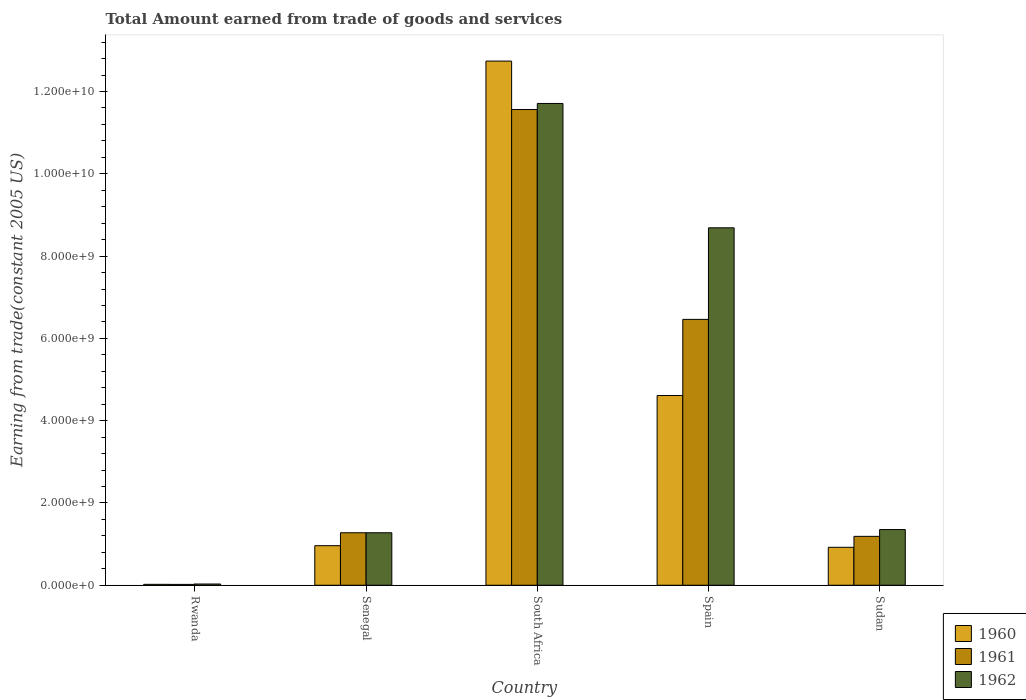How many different coloured bars are there?
Make the answer very short. 3. How many bars are there on the 3rd tick from the left?
Offer a very short reply. 3. How many bars are there on the 1st tick from the right?
Make the answer very short. 3. What is the label of the 2nd group of bars from the left?
Ensure brevity in your answer.  Senegal. In how many cases, is the number of bars for a given country not equal to the number of legend labels?
Keep it short and to the point. 0. What is the total amount earned by trading goods and services in 1962 in Sudan?
Give a very brief answer. 1.35e+09. Across all countries, what is the maximum total amount earned by trading goods and services in 1962?
Your answer should be very brief. 1.17e+1. Across all countries, what is the minimum total amount earned by trading goods and services in 1960?
Give a very brief answer. 2.20e+07. In which country was the total amount earned by trading goods and services in 1960 maximum?
Your answer should be compact. South Africa. In which country was the total amount earned by trading goods and services in 1960 minimum?
Provide a succinct answer. Rwanda. What is the total total amount earned by trading goods and services in 1960 in the graph?
Ensure brevity in your answer.  1.93e+1. What is the difference between the total amount earned by trading goods and services in 1962 in South Africa and that in Sudan?
Offer a very short reply. 1.04e+1. What is the difference between the total amount earned by trading goods and services in 1962 in South Africa and the total amount earned by trading goods and services in 1961 in Spain?
Ensure brevity in your answer.  5.25e+09. What is the average total amount earned by trading goods and services in 1961 per country?
Your answer should be very brief. 4.10e+09. What is the difference between the total amount earned by trading goods and services of/in 1962 and total amount earned by trading goods and services of/in 1960 in Spain?
Offer a very short reply. 4.08e+09. What is the ratio of the total amount earned by trading goods and services in 1962 in Senegal to that in Sudan?
Your answer should be compact. 0.94. Is the total amount earned by trading goods and services in 1960 in Senegal less than that in South Africa?
Give a very brief answer. Yes. What is the difference between the highest and the second highest total amount earned by trading goods and services in 1961?
Provide a succinct answer. -5.19e+09. What is the difference between the highest and the lowest total amount earned by trading goods and services in 1962?
Provide a succinct answer. 1.17e+1. Is it the case that in every country, the sum of the total amount earned by trading goods and services in 1961 and total amount earned by trading goods and services in 1962 is greater than the total amount earned by trading goods and services in 1960?
Give a very brief answer. Yes. Are all the bars in the graph horizontal?
Ensure brevity in your answer.  No. How many countries are there in the graph?
Make the answer very short. 5. What is the difference between two consecutive major ticks on the Y-axis?
Your answer should be compact. 2.00e+09. Does the graph contain any zero values?
Provide a short and direct response. No. Where does the legend appear in the graph?
Your answer should be compact. Bottom right. How are the legend labels stacked?
Ensure brevity in your answer.  Vertical. What is the title of the graph?
Offer a terse response. Total Amount earned from trade of goods and services. What is the label or title of the Y-axis?
Provide a succinct answer. Earning from trade(constant 2005 US). What is the Earning from trade(constant 2005 US) of 1960 in Rwanda?
Provide a short and direct response. 2.20e+07. What is the Earning from trade(constant 2005 US) in 1961 in Rwanda?
Provide a short and direct response. 2.05e+07. What is the Earning from trade(constant 2005 US) of 1962 in Rwanda?
Give a very brief answer. 2.97e+07. What is the Earning from trade(constant 2005 US) of 1960 in Senegal?
Your answer should be compact. 9.62e+08. What is the Earning from trade(constant 2005 US) in 1961 in Senegal?
Give a very brief answer. 1.28e+09. What is the Earning from trade(constant 2005 US) in 1962 in Senegal?
Provide a short and direct response. 1.28e+09. What is the Earning from trade(constant 2005 US) of 1960 in South Africa?
Offer a terse response. 1.27e+1. What is the Earning from trade(constant 2005 US) in 1961 in South Africa?
Provide a succinct answer. 1.16e+1. What is the Earning from trade(constant 2005 US) in 1962 in South Africa?
Ensure brevity in your answer.  1.17e+1. What is the Earning from trade(constant 2005 US) in 1960 in Spain?
Ensure brevity in your answer.  4.61e+09. What is the Earning from trade(constant 2005 US) in 1961 in Spain?
Give a very brief answer. 6.46e+09. What is the Earning from trade(constant 2005 US) in 1962 in Spain?
Give a very brief answer. 8.69e+09. What is the Earning from trade(constant 2005 US) of 1960 in Sudan?
Keep it short and to the point. 9.22e+08. What is the Earning from trade(constant 2005 US) of 1961 in Sudan?
Provide a short and direct response. 1.19e+09. What is the Earning from trade(constant 2005 US) of 1962 in Sudan?
Offer a very short reply. 1.35e+09. Across all countries, what is the maximum Earning from trade(constant 2005 US) in 1960?
Your answer should be very brief. 1.27e+1. Across all countries, what is the maximum Earning from trade(constant 2005 US) of 1961?
Your response must be concise. 1.16e+1. Across all countries, what is the maximum Earning from trade(constant 2005 US) of 1962?
Make the answer very short. 1.17e+1. Across all countries, what is the minimum Earning from trade(constant 2005 US) of 1960?
Ensure brevity in your answer.  2.20e+07. Across all countries, what is the minimum Earning from trade(constant 2005 US) of 1961?
Offer a very short reply. 2.05e+07. Across all countries, what is the minimum Earning from trade(constant 2005 US) in 1962?
Your answer should be compact. 2.97e+07. What is the total Earning from trade(constant 2005 US) in 1960 in the graph?
Provide a succinct answer. 1.93e+1. What is the total Earning from trade(constant 2005 US) of 1961 in the graph?
Your answer should be compact. 2.05e+1. What is the total Earning from trade(constant 2005 US) of 1962 in the graph?
Give a very brief answer. 2.31e+1. What is the difference between the Earning from trade(constant 2005 US) of 1960 in Rwanda and that in Senegal?
Provide a succinct answer. -9.40e+08. What is the difference between the Earning from trade(constant 2005 US) in 1961 in Rwanda and that in Senegal?
Ensure brevity in your answer.  -1.26e+09. What is the difference between the Earning from trade(constant 2005 US) in 1962 in Rwanda and that in Senegal?
Provide a short and direct response. -1.25e+09. What is the difference between the Earning from trade(constant 2005 US) in 1960 in Rwanda and that in South Africa?
Provide a short and direct response. -1.27e+1. What is the difference between the Earning from trade(constant 2005 US) in 1961 in Rwanda and that in South Africa?
Offer a terse response. -1.15e+1. What is the difference between the Earning from trade(constant 2005 US) of 1962 in Rwanda and that in South Africa?
Give a very brief answer. -1.17e+1. What is the difference between the Earning from trade(constant 2005 US) of 1960 in Rwanda and that in Spain?
Keep it short and to the point. -4.59e+09. What is the difference between the Earning from trade(constant 2005 US) of 1961 in Rwanda and that in Spain?
Your answer should be compact. -6.44e+09. What is the difference between the Earning from trade(constant 2005 US) of 1962 in Rwanda and that in Spain?
Ensure brevity in your answer.  -8.66e+09. What is the difference between the Earning from trade(constant 2005 US) of 1960 in Rwanda and that in Sudan?
Give a very brief answer. -9.00e+08. What is the difference between the Earning from trade(constant 2005 US) of 1961 in Rwanda and that in Sudan?
Offer a terse response. -1.17e+09. What is the difference between the Earning from trade(constant 2005 US) in 1962 in Rwanda and that in Sudan?
Your response must be concise. -1.32e+09. What is the difference between the Earning from trade(constant 2005 US) in 1960 in Senegal and that in South Africa?
Make the answer very short. -1.18e+1. What is the difference between the Earning from trade(constant 2005 US) of 1961 in Senegal and that in South Africa?
Your response must be concise. -1.03e+1. What is the difference between the Earning from trade(constant 2005 US) in 1962 in Senegal and that in South Africa?
Offer a terse response. -1.04e+1. What is the difference between the Earning from trade(constant 2005 US) in 1960 in Senegal and that in Spain?
Make the answer very short. -3.65e+09. What is the difference between the Earning from trade(constant 2005 US) of 1961 in Senegal and that in Spain?
Offer a terse response. -5.19e+09. What is the difference between the Earning from trade(constant 2005 US) of 1962 in Senegal and that in Spain?
Your response must be concise. -7.41e+09. What is the difference between the Earning from trade(constant 2005 US) of 1960 in Senegal and that in Sudan?
Ensure brevity in your answer.  3.97e+07. What is the difference between the Earning from trade(constant 2005 US) in 1961 in Senegal and that in Sudan?
Offer a terse response. 8.73e+07. What is the difference between the Earning from trade(constant 2005 US) in 1962 in Senegal and that in Sudan?
Offer a terse response. -7.77e+07. What is the difference between the Earning from trade(constant 2005 US) of 1960 in South Africa and that in Spain?
Your answer should be compact. 8.13e+09. What is the difference between the Earning from trade(constant 2005 US) of 1961 in South Africa and that in Spain?
Provide a short and direct response. 5.10e+09. What is the difference between the Earning from trade(constant 2005 US) of 1962 in South Africa and that in Spain?
Provide a short and direct response. 3.02e+09. What is the difference between the Earning from trade(constant 2005 US) of 1960 in South Africa and that in Sudan?
Your response must be concise. 1.18e+1. What is the difference between the Earning from trade(constant 2005 US) of 1961 in South Africa and that in Sudan?
Provide a succinct answer. 1.04e+1. What is the difference between the Earning from trade(constant 2005 US) in 1962 in South Africa and that in Sudan?
Your answer should be very brief. 1.04e+1. What is the difference between the Earning from trade(constant 2005 US) in 1960 in Spain and that in Sudan?
Make the answer very short. 3.69e+09. What is the difference between the Earning from trade(constant 2005 US) of 1961 in Spain and that in Sudan?
Make the answer very short. 5.27e+09. What is the difference between the Earning from trade(constant 2005 US) of 1962 in Spain and that in Sudan?
Your answer should be very brief. 7.33e+09. What is the difference between the Earning from trade(constant 2005 US) in 1960 in Rwanda and the Earning from trade(constant 2005 US) in 1961 in Senegal?
Provide a succinct answer. -1.25e+09. What is the difference between the Earning from trade(constant 2005 US) of 1960 in Rwanda and the Earning from trade(constant 2005 US) of 1962 in Senegal?
Give a very brief answer. -1.25e+09. What is the difference between the Earning from trade(constant 2005 US) in 1961 in Rwanda and the Earning from trade(constant 2005 US) in 1962 in Senegal?
Offer a terse response. -1.26e+09. What is the difference between the Earning from trade(constant 2005 US) of 1960 in Rwanda and the Earning from trade(constant 2005 US) of 1961 in South Africa?
Your answer should be compact. -1.15e+1. What is the difference between the Earning from trade(constant 2005 US) in 1960 in Rwanda and the Earning from trade(constant 2005 US) in 1962 in South Africa?
Your answer should be compact. -1.17e+1. What is the difference between the Earning from trade(constant 2005 US) of 1961 in Rwanda and the Earning from trade(constant 2005 US) of 1962 in South Africa?
Provide a short and direct response. -1.17e+1. What is the difference between the Earning from trade(constant 2005 US) in 1960 in Rwanda and the Earning from trade(constant 2005 US) in 1961 in Spain?
Ensure brevity in your answer.  -6.44e+09. What is the difference between the Earning from trade(constant 2005 US) in 1960 in Rwanda and the Earning from trade(constant 2005 US) in 1962 in Spain?
Offer a terse response. -8.67e+09. What is the difference between the Earning from trade(constant 2005 US) in 1961 in Rwanda and the Earning from trade(constant 2005 US) in 1962 in Spain?
Offer a terse response. -8.67e+09. What is the difference between the Earning from trade(constant 2005 US) in 1960 in Rwanda and the Earning from trade(constant 2005 US) in 1961 in Sudan?
Provide a succinct answer. -1.17e+09. What is the difference between the Earning from trade(constant 2005 US) in 1960 in Rwanda and the Earning from trade(constant 2005 US) in 1962 in Sudan?
Provide a succinct answer. -1.33e+09. What is the difference between the Earning from trade(constant 2005 US) in 1961 in Rwanda and the Earning from trade(constant 2005 US) in 1962 in Sudan?
Ensure brevity in your answer.  -1.33e+09. What is the difference between the Earning from trade(constant 2005 US) in 1960 in Senegal and the Earning from trade(constant 2005 US) in 1961 in South Africa?
Keep it short and to the point. -1.06e+1. What is the difference between the Earning from trade(constant 2005 US) in 1960 in Senegal and the Earning from trade(constant 2005 US) in 1962 in South Africa?
Offer a terse response. -1.07e+1. What is the difference between the Earning from trade(constant 2005 US) of 1961 in Senegal and the Earning from trade(constant 2005 US) of 1962 in South Africa?
Give a very brief answer. -1.04e+1. What is the difference between the Earning from trade(constant 2005 US) of 1960 in Senegal and the Earning from trade(constant 2005 US) of 1961 in Spain?
Your response must be concise. -5.50e+09. What is the difference between the Earning from trade(constant 2005 US) in 1960 in Senegal and the Earning from trade(constant 2005 US) in 1962 in Spain?
Offer a terse response. -7.73e+09. What is the difference between the Earning from trade(constant 2005 US) in 1961 in Senegal and the Earning from trade(constant 2005 US) in 1962 in Spain?
Your response must be concise. -7.41e+09. What is the difference between the Earning from trade(constant 2005 US) in 1960 in Senegal and the Earning from trade(constant 2005 US) in 1961 in Sudan?
Your response must be concise. -2.27e+08. What is the difference between the Earning from trade(constant 2005 US) in 1960 in Senegal and the Earning from trade(constant 2005 US) in 1962 in Sudan?
Make the answer very short. -3.92e+08. What is the difference between the Earning from trade(constant 2005 US) in 1961 in Senegal and the Earning from trade(constant 2005 US) in 1962 in Sudan?
Offer a very short reply. -7.77e+07. What is the difference between the Earning from trade(constant 2005 US) of 1960 in South Africa and the Earning from trade(constant 2005 US) of 1961 in Spain?
Provide a succinct answer. 6.28e+09. What is the difference between the Earning from trade(constant 2005 US) in 1960 in South Africa and the Earning from trade(constant 2005 US) in 1962 in Spain?
Your answer should be very brief. 4.05e+09. What is the difference between the Earning from trade(constant 2005 US) in 1961 in South Africa and the Earning from trade(constant 2005 US) in 1962 in Spain?
Keep it short and to the point. 2.88e+09. What is the difference between the Earning from trade(constant 2005 US) in 1960 in South Africa and the Earning from trade(constant 2005 US) in 1961 in Sudan?
Provide a short and direct response. 1.16e+1. What is the difference between the Earning from trade(constant 2005 US) in 1960 in South Africa and the Earning from trade(constant 2005 US) in 1962 in Sudan?
Offer a terse response. 1.14e+1. What is the difference between the Earning from trade(constant 2005 US) in 1961 in South Africa and the Earning from trade(constant 2005 US) in 1962 in Sudan?
Offer a terse response. 1.02e+1. What is the difference between the Earning from trade(constant 2005 US) of 1960 in Spain and the Earning from trade(constant 2005 US) of 1961 in Sudan?
Give a very brief answer. 3.42e+09. What is the difference between the Earning from trade(constant 2005 US) in 1960 in Spain and the Earning from trade(constant 2005 US) in 1962 in Sudan?
Your answer should be very brief. 3.26e+09. What is the difference between the Earning from trade(constant 2005 US) in 1961 in Spain and the Earning from trade(constant 2005 US) in 1962 in Sudan?
Offer a very short reply. 5.11e+09. What is the average Earning from trade(constant 2005 US) in 1960 per country?
Your response must be concise. 3.85e+09. What is the average Earning from trade(constant 2005 US) in 1961 per country?
Provide a short and direct response. 4.10e+09. What is the average Earning from trade(constant 2005 US) of 1962 per country?
Provide a short and direct response. 4.61e+09. What is the difference between the Earning from trade(constant 2005 US) in 1960 and Earning from trade(constant 2005 US) in 1961 in Rwanda?
Your response must be concise. 1.46e+06. What is the difference between the Earning from trade(constant 2005 US) in 1960 and Earning from trade(constant 2005 US) in 1962 in Rwanda?
Offer a terse response. -7.74e+06. What is the difference between the Earning from trade(constant 2005 US) in 1961 and Earning from trade(constant 2005 US) in 1962 in Rwanda?
Give a very brief answer. -9.20e+06. What is the difference between the Earning from trade(constant 2005 US) in 1960 and Earning from trade(constant 2005 US) in 1961 in Senegal?
Ensure brevity in your answer.  -3.14e+08. What is the difference between the Earning from trade(constant 2005 US) in 1960 and Earning from trade(constant 2005 US) in 1962 in Senegal?
Offer a very short reply. -3.14e+08. What is the difference between the Earning from trade(constant 2005 US) of 1960 and Earning from trade(constant 2005 US) of 1961 in South Africa?
Your answer should be very brief. 1.18e+09. What is the difference between the Earning from trade(constant 2005 US) of 1960 and Earning from trade(constant 2005 US) of 1962 in South Africa?
Provide a short and direct response. 1.03e+09. What is the difference between the Earning from trade(constant 2005 US) of 1961 and Earning from trade(constant 2005 US) of 1962 in South Africa?
Ensure brevity in your answer.  -1.46e+08. What is the difference between the Earning from trade(constant 2005 US) in 1960 and Earning from trade(constant 2005 US) in 1961 in Spain?
Your response must be concise. -1.85e+09. What is the difference between the Earning from trade(constant 2005 US) of 1960 and Earning from trade(constant 2005 US) of 1962 in Spain?
Provide a short and direct response. -4.08e+09. What is the difference between the Earning from trade(constant 2005 US) in 1961 and Earning from trade(constant 2005 US) in 1962 in Spain?
Provide a succinct answer. -2.23e+09. What is the difference between the Earning from trade(constant 2005 US) of 1960 and Earning from trade(constant 2005 US) of 1961 in Sudan?
Keep it short and to the point. -2.66e+08. What is the difference between the Earning from trade(constant 2005 US) of 1960 and Earning from trade(constant 2005 US) of 1962 in Sudan?
Your answer should be very brief. -4.31e+08. What is the difference between the Earning from trade(constant 2005 US) in 1961 and Earning from trade(constant 2005 US) in 1962 in Sudan?
Make the answer very short. -1.65e+08. What is the ratio of the Earning from trade(constant 2005 US) of 1960 in Rwanda to that in Senegal?
Offer a very short reply. 0.02. What is the ratio of the Earning from trade(constant 2005 US) in 1961 in Rwanda to that in Senegal?
Your answer should be compact. 0.02. What is the ratio of the Earning from trade(constant 2005 US) in 1962 in Rwanda to that in Senegal?
Make the answer very short. 0.02. What is the ratio of the Earning from trade(constant 2005 US) in 1960 in Rwanda to that in South Africa?
Give a very brief answer. 0. What is the ratio of the Earning from trade(constant 2005 US) of 1961 in Rwanda to that in South Africa?
Your response must be concise. 0. What is the ratio of the Earning from trade(constant 2005 US) of 1962 in Rwanda to that in South Africa?
Offer a terse response. 0. What is the ratio of the Earning from trade(constant 2005 US) of 1960 in Rwanda to that in Spain?
Offer a very short reply. 0. What is the ratio of the Earning from trade(constant 2005 US) of 1961 in Rwanda to that in Spain?
Your answer should be compact. 0. What is the ratio of the Earning from trade(constant 2005 US) in 1962 in Rwanda to that in Spain?
Make the answer very short. 0. What is the ratio of the Earning from trade(constant 2005 US) of 1960 in Rwanda to that in Sudan?
Provide a succinct answer. 0.02. What is the ratio of the Earning from trade(constant 2005 US) of 1961 in Rwanda to that in Sudan?
Your response must be concise. 0.02. What is the ratio of the Earning from trade(constant 2005 US) of 1962 in Rwanda to that in Sudan?
Offer a very short reply. 0.02. What is the ratio of the Earning from trade(constant 2005 US) of 1960 in Senegal to that in South Africa?
Keep it short and to the point. 0.08. What is the ratio of the Earning from trade(constant 2005 US) in 1961 in Senegal to that in South Africa?
Keep it short and to the point. 0.11. What is the ratio of the Earning from trade(constant 2005 US) of 1962 in Senegal to that in South Africa?
Your response must be concise. 0.11. What is the ratio of the Earning from trade(constant 2005 US) in 1960 in Senegal to that in Spain?
Offer a terse response. 0.21. What is the ratio of the Earning from trade(constant 2005 US) of 1961 in Senegal to that in Spain?
Provide a succinct answer. 0.2. What is the ratio of the Earning from trade(constant 2005 US) in 1962 in Senegal to that in Spain?
Ensure brevity in your answer.  0.15. What is the ratio of the Earning from trade(constant 2005 US) in 1960 in Senegal to that in Sudan?
Offer a very short reply. 1.04. What is the ratio of the Earning from trade(constant 2005 US) of 1961 in Senegal to that in Sudan?
Provide a succinct answer. 1.07. What is the ratio of the Earning from trade(constant 2005 US) of 1962 in Senegal to that in Sudan?
Make the answer very short. 0.94. What is the ratio of the Earning from trade(constant 2005 US) of 1960 in South Africa to that in Spain?
Make the answer very short. 2.76. What is the ratio of the Earning from trade(constant 2005 US) of 1961 in South Africa to that in Spain?
Your answer should be very brief. 1.79. What is the ratio of the Earning from trade(constant 2005 US) of 1962 in South Africa to that in Spain?
Your response must be concise. 1.35. What is the ratio of the Earning from trade(constant 2005 US) of 1960 in South Africa to that in Sudan?
Your answer should be compact. 13.82. What is the ratio of the Earning from trade(constant 2005 US) of 1961 in South Africa to that in Sudan?
Give a very brief answer. 9.73. What is the ratio of the Earning from trade(constant 2005 US) in 1962 in South Africa to that in Sudan?
Offer a terse response. 8.65. What is the ratio of the Earning from trade(constant 2005 US) in 1960 in Spain to that in Sudan?
Offer a very short reply. 5. What is the ratio of the Earning from trade(constant 2005 US) in 1961 in Spain to that in Sudan?
Keep it short and to the point. 5.44. What is the ratio of the Earning from trade(constant 2005 US) in 1962 in Spain to that in Sudan?
Provide a short and direct response. 6.42. What is the difference between the highest and the second highest Earning from trade(constant 2005 US) of 1960?
Provide a succinct answer. 8.13e+09. What is the difference between the highest and the second highest Earning from trade(constant 2005 US) of 1961?
Offer a very short reply. 5.10e+09. What is the difference between the highest and the second highest Earning from trade(constant 2005 US) in 1962?
Offer a very short reply. 3.02e+09. What is the difference between the highest and the lowest Earning from trade(constant 2005 US) of 1960?
Provide a short and direct response. 1.27e+1. What is the difference between the highest and the lowest Earning from trade(constant 2005 US) in 1961?
Provide a succinct answer. 1.15e+1. What is the difference between the highest and the lowest Earning from trade(constant 2005 US) of 1962?
Your answer should be very brief. 1.17e+1. 